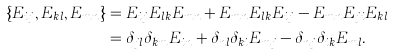<formula> <loc_0><loc_0><loc_500><loc_500>\{ E _ { i j } , E _ { k l } , E _ { m n } \} & = E _ { i j } E _ { l k } E _ { m n } + E _ { m n } E _ { l k } E _ { i j } - E _ { m n } E _ { j i } E _ { k l } \\ & = \delta _ { j l } \delta _ { k m } E _ { i n } + \delta _ { n l } \delta _ { k i } E _ { m j } - \delta _ { n j } \delta _ { i k } E _ { m l } .</formula> 